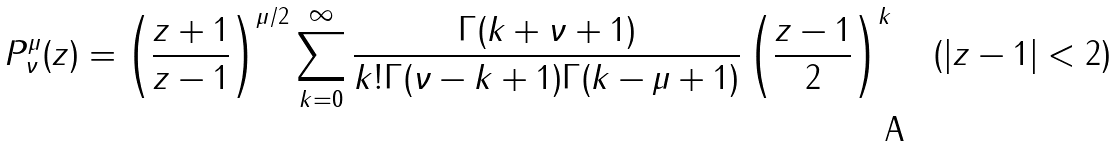<formula> <loc_0><loc_0><loc_500><loc_500>P _ { \nu } ^ { \mu } ( z ) = \left ( \frac { z + 1 } { z - 1 } \right ) ^ { \mu / 2 } \sum _ { k = 0 } ^ { \infty } \frac { \Gamma ( k + \nu + 1 ) } { k ! \Gamma ( \nu - k + 1 ) \Gamma ( k - \mu + 1 ) } \left ( \frac { z - 1 } { 2 } \right ) ^ { k } \quad ( | z - 1 | < 2 )</formula> 